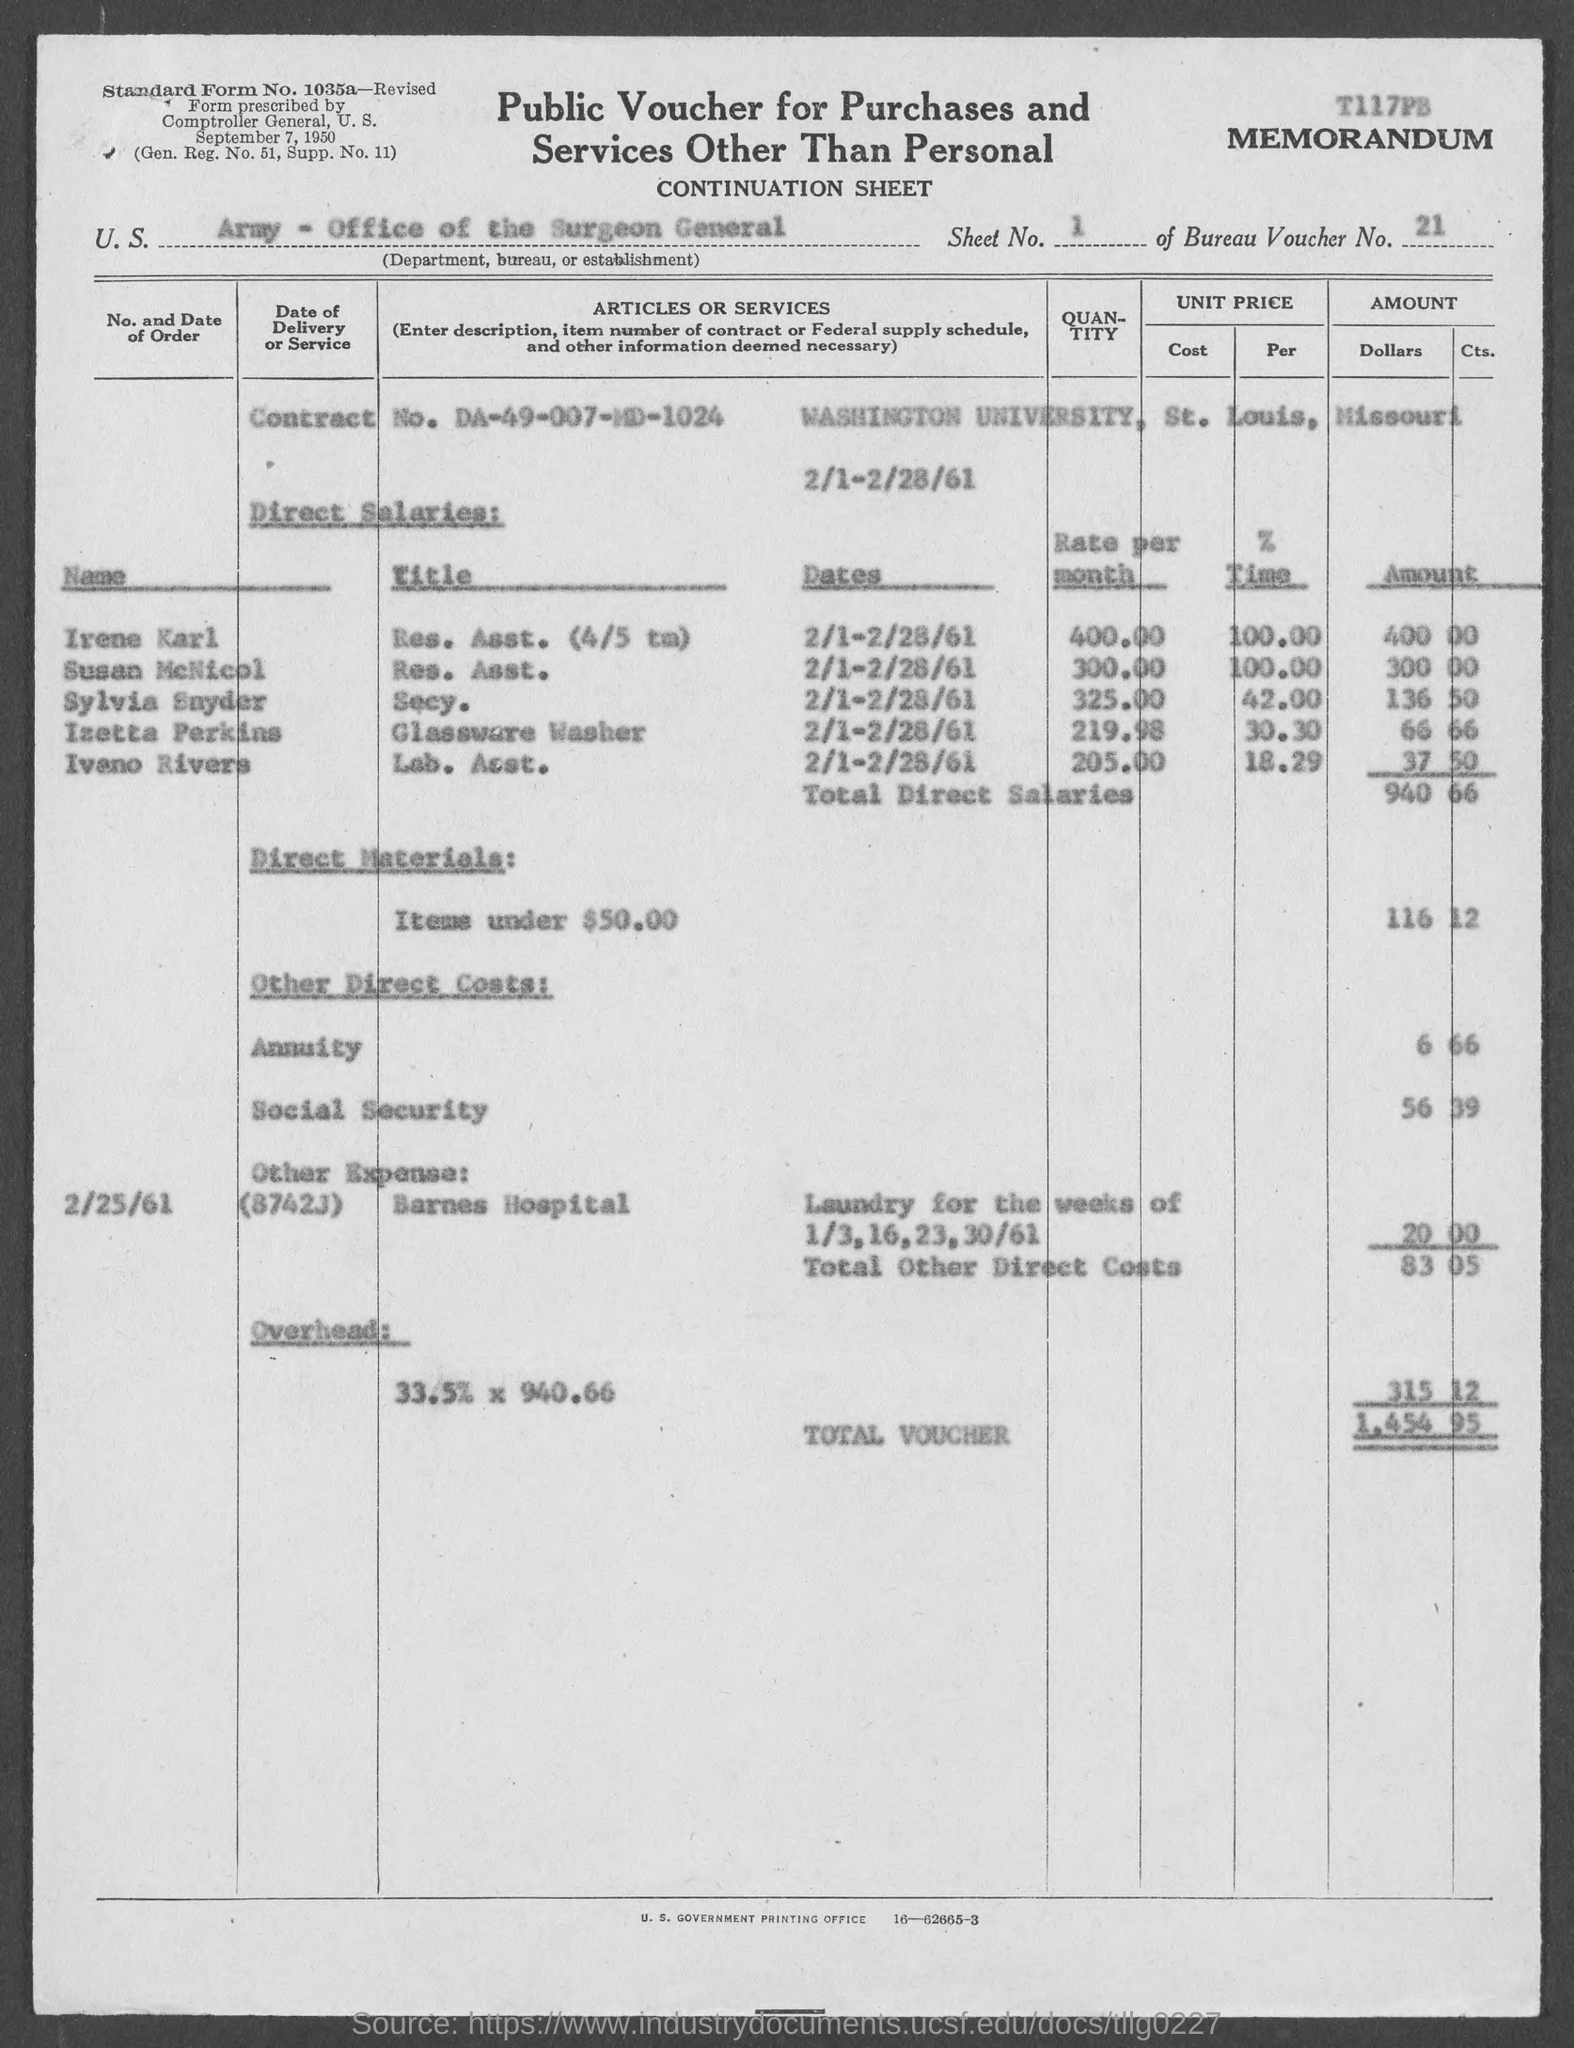Indicate a few pertinent items in this graphic. The Bureau Voucher Number mentioned in the document is 21. Please indicate the sheet number mentioned in the voucher as 1... The direct salaries cost mentioned in the voucher is 940.66. The social security cost mentioned in the voucher is 56 yuan and 39 yuan. The voucher contains a standard form number, 1035a-Revised, that needs to be provided. 